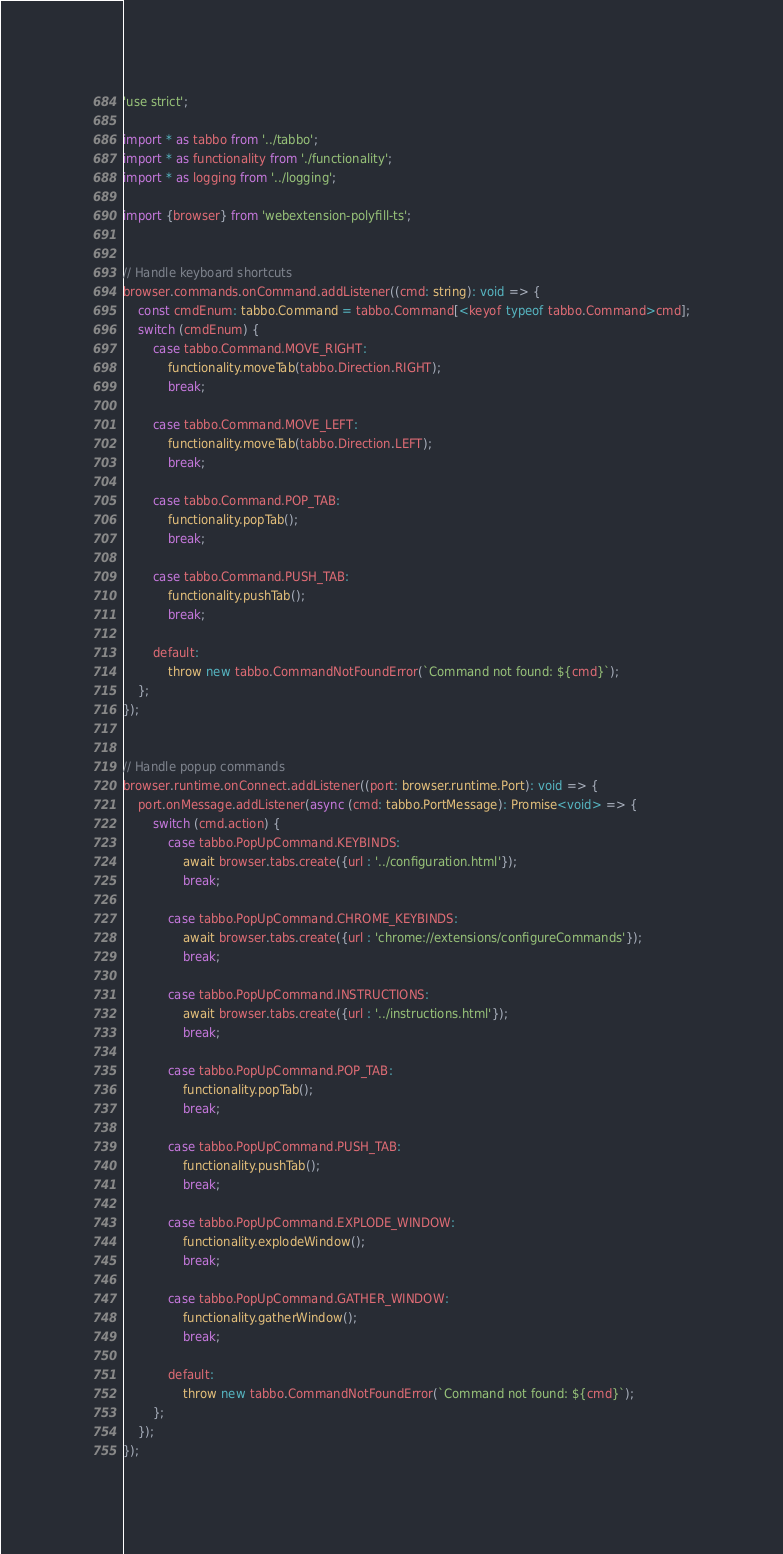Convert code to text. <code><loc_0><loc_0><loc_500><loc_500><_TypeScript_>'use strict';

import * as tabbo from '../tabbo';
import * as functionality from './functionality';
import * as logging from '../logging';

import {browser} from 'webextension-polyfill-ts';


// Handle keyboard shortcuts
browser.commands.onCommand.addListener((cmd: string): void => {
	const cmdEnum: tabbo.Command = tabbo.Command[<keyof typeof tabbo.Command>cmd];
	switch (cmdEnum) {
		case tabbo.Command.MOVE_RIGHT:
			functionality.moveTab(tabbo.Direction.RIGHT);
			break;

		case tabbo.Command.MOVE_LEFT:
			functionality.moveTab(tabbo.Direction.LEFT);
			break;

		case tabbo.Command.POP_TAB:
			functionality.popTab();
			break;

		case tabbo.Command.PUSH_TAB:
			functionality.pushTab();
			break;

		default:
			throw new tabbo.CommandNotFoundError(`Command not found: ${cmd}`);
	};
});


// Handle popup commands
browser.runtime.onConnect.addListener((port: browser.runtime.Port): void => {
	port.onMessage.addListener(async (cmd: tabbo.PortMessage): Promise<void> => {
		switch (cmd.action) {
			case tabbo.PopUpCommand.KEYBINDS:
				await browser.tabs.create({url : '../configuration.html'});
				break;

			case tabbo.PopUpCommand.CHROME_KEYBINDS:
				await browser.tabs.create({url : 'chrome://extensions/configureCommands'});
				break;

			case tabbo.PopUpCommand.INSTRUCTIONS:
				await browser.tabs.create({url : '../instructions.html'});
				break;

			case tabbo.PopUpCommand.POP_TAB:
				functionality.popTab();
				break;

			case tabbo.PopUpCommand.PUSH_TAB:
				functionality.pushTab();
				break;

			case tabbo.PopUpCommand.EXPLODE_WINDOW:
				functionality.explodeWindow();
				break;

			case tabbo.PopUpCommand.GATHER_WINDOW:
				functionality.gatherWindow();
				break;

			default:
				throw new tabbo.CommandNotFoundError(`Command not found: ${cmd}`);
		};
	});
});
</code> 